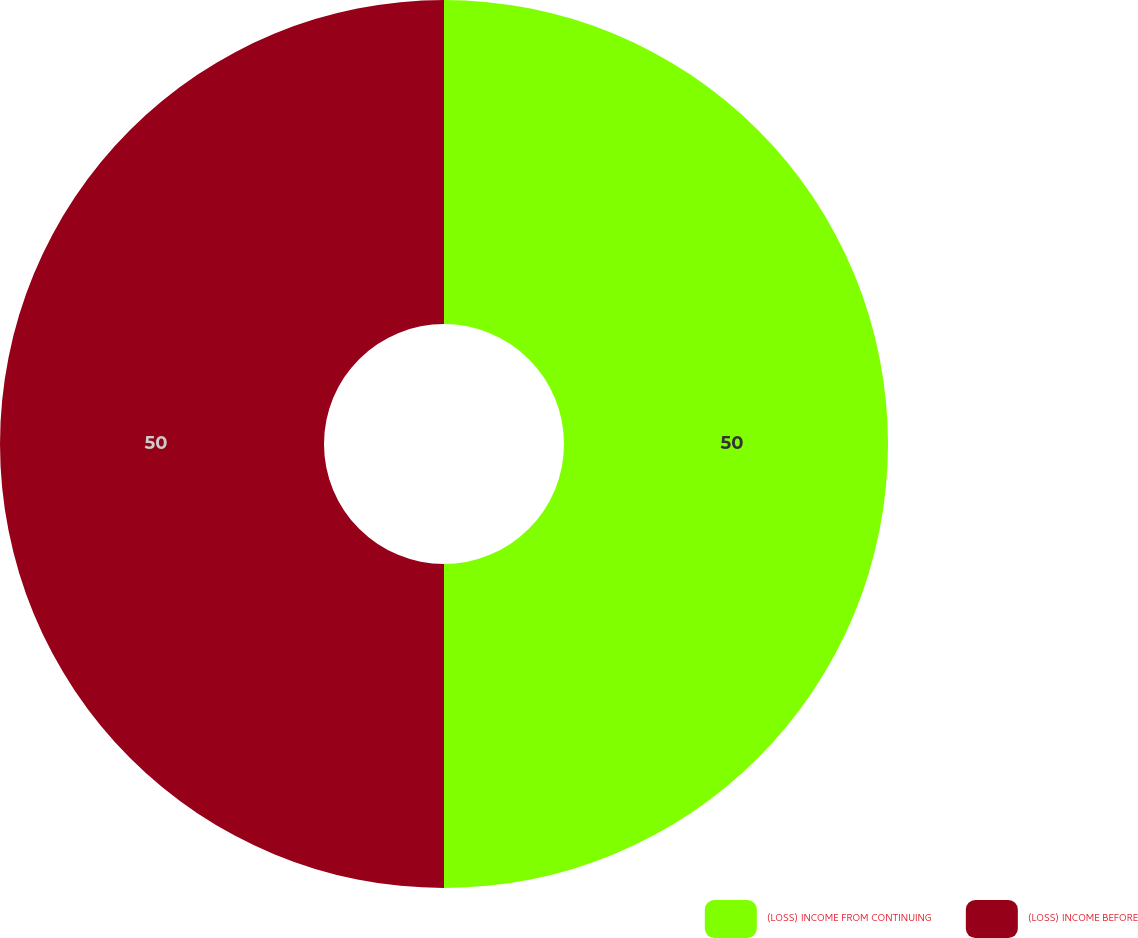Convert chart to OTSL. <chart><loc_0><loc_0><loc_500><loc_500><pie_chart><fcel>(LOSS) INCOME FROM CONTINUING<fcel>(LOSS) INCOME BEFORE<nl><fcel>50.0%<fcel>50.0%<nl></chart> 